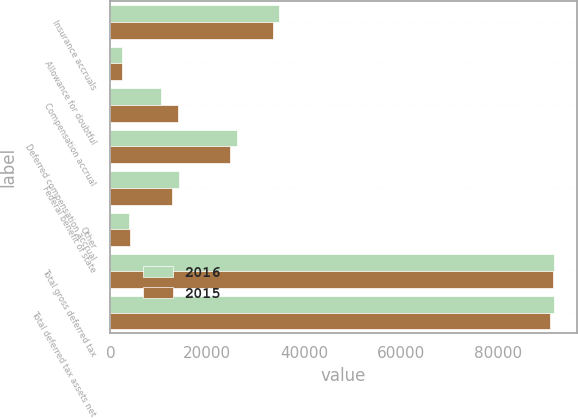<chart> <loc_0><loc_0><loc_500><loc_500><stacked_bar_chart><ecel><fcel>Insurance accruals<fcel>Allowance for doubtful<fcel>Compensation accrual<fcel>Deferred compensation accrual<fcel>Federal benefit of state<fcel>Other<fcel>Total gross deferred tax<fcel>Total deferred tax assets net<nl><fcel>2016<fcel>34788<fcel>2347<fcel>10443<fcel>26062<fcel>14085<fcel>3853<fcel>91578<fcel>91578<nl><fcel>2015<fcel>33522<fcel>2335<fcel>13991<fcel>24687<fcel>12751<fcel>4036<fcel>91322<fcel>90770<nl></chart> 